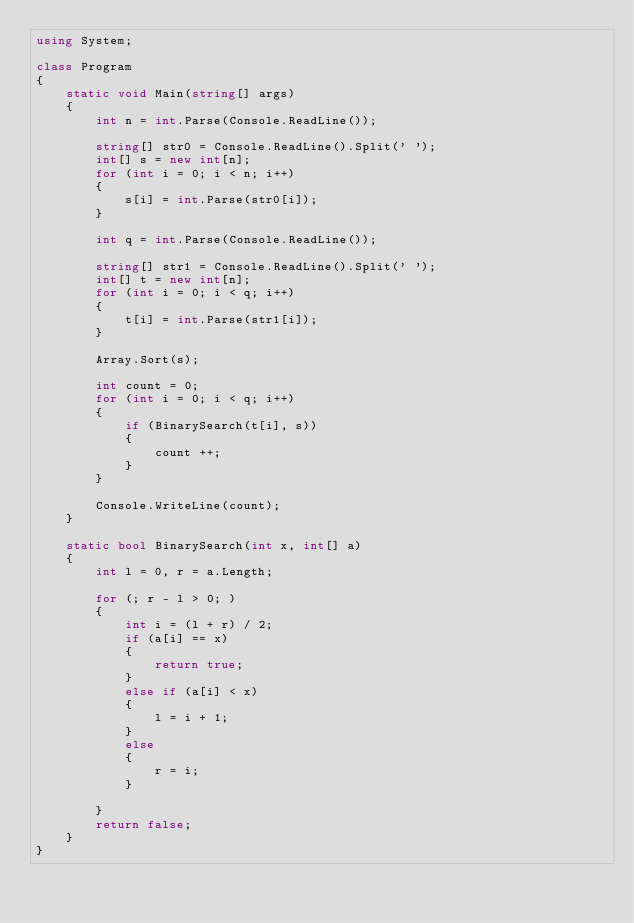<code> <loc_0><loc_0><loc_500><loc_500><_C#_>using System;
 
class Program
{
    static void Main(string[] args)
    {
        int n = int.Parse(Console.ReadLine());
         
        string[] str0 = Console.ReadLine().Split(' ');
        int[] s = new int[n];
        for (int i = 0; i < n; i++)
        {
            s[i] = int.Parse(str0[i]);
        }
 
        int q = int.Parse(Console.ReadLine());
         
        string[] str1 = Console.ReadLine().Split(' ');
        int[] t = new int[n];
        for (int i = 0; i < q; i++)
        {
            t[i] = int.Parse(str1[i]);
        }

		Array.Sort(s);
 
        int count = 0;
        for (int i = 0; i < q; i++)
        {
            if (BinarySearch(t[i], s))
			{
				count ++;
			}
        }
 
        Console.WriteLine(count);
    }

	static bool BinarySearch(int x, int[] a)
	{
		int l = 0, r = a.Length;

		for (; r - l > 0; )
		{
			int i = (l + r) / 2;
			if (a[i] == x)
			{
				return true;
			}
			else if (a[i] < x)
			{
				l = i + 1;
			}
			else
			{
				r = i;
			}

		}
		return false;
	}
}
</code> 